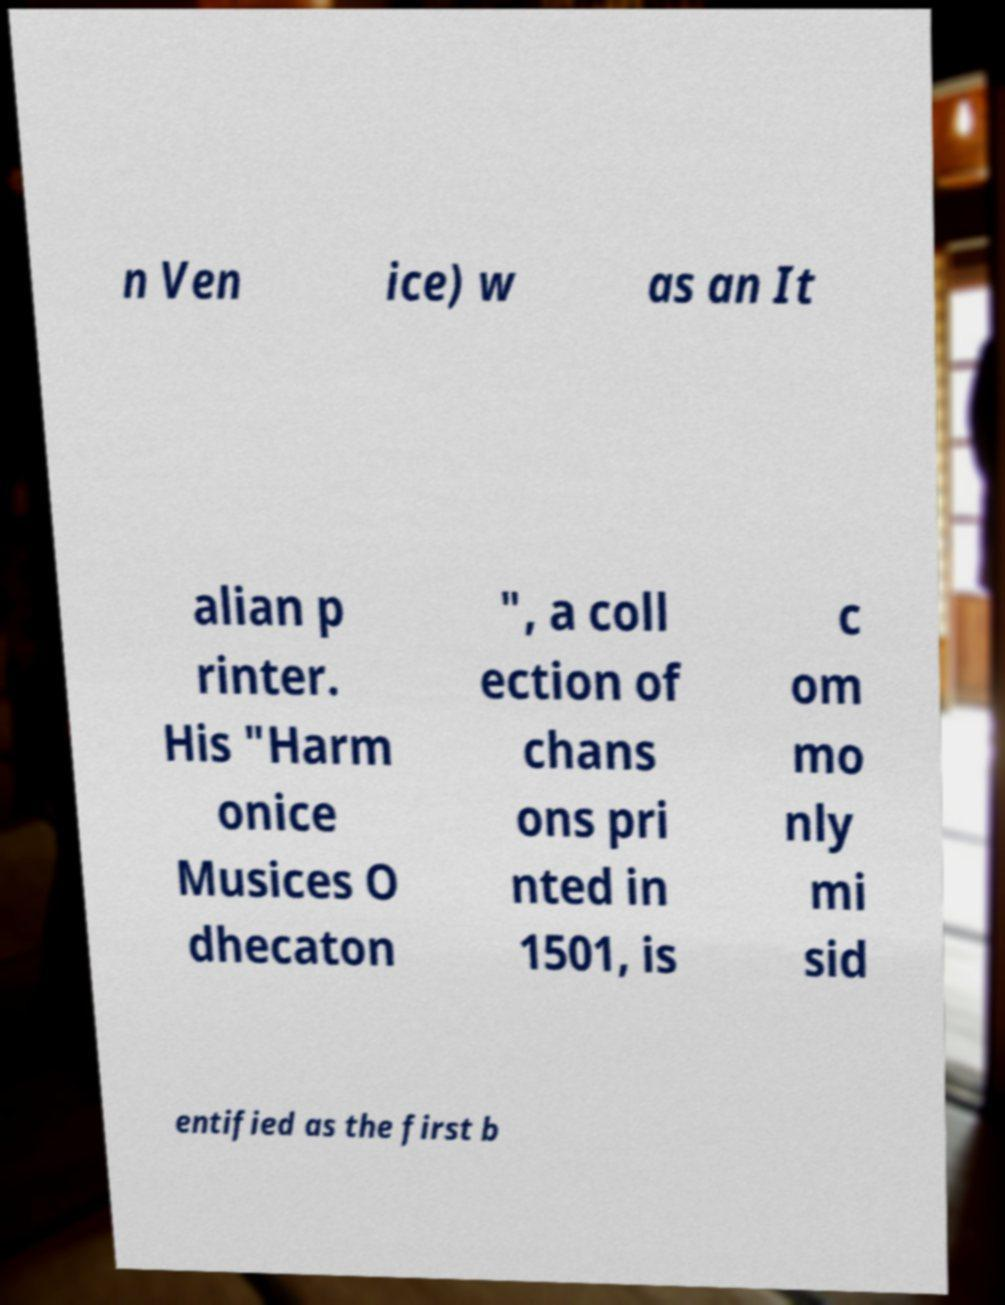Please identify and transcribe the text found in this image. n Ven ice) w as an It alian p rinter. His "Harm onice Musices O dhecaton ", a coll ection of chans ons pri nted in 1501, is c om mo nly mi sid entified as the first b 